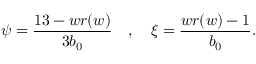Convert formula to latex. <formula><loc_0><loc_0><loc_500><loc_500>\psi = \frac { 1 3 - w r ( w ) } { 3 b _ { 0 } } \quad , \quad \xi = \frac { w r ( w ) - 1 } { b _ { 0 } } .</formula> 